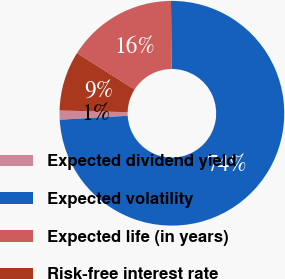Convert chart. <chart><loc_0><loc_0><loc_500><loc_500><pie_chart><fcel>Expected dividend yield<fcel>Expected volatility<fcel>Expected life (in years)<fcel>Risk-free interest rate<nl><fcel>1.31%<fcel>74.21%<fcel>15.88%<fcel>8.6%<nl></chart> 